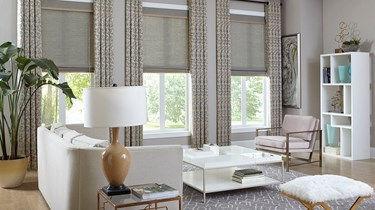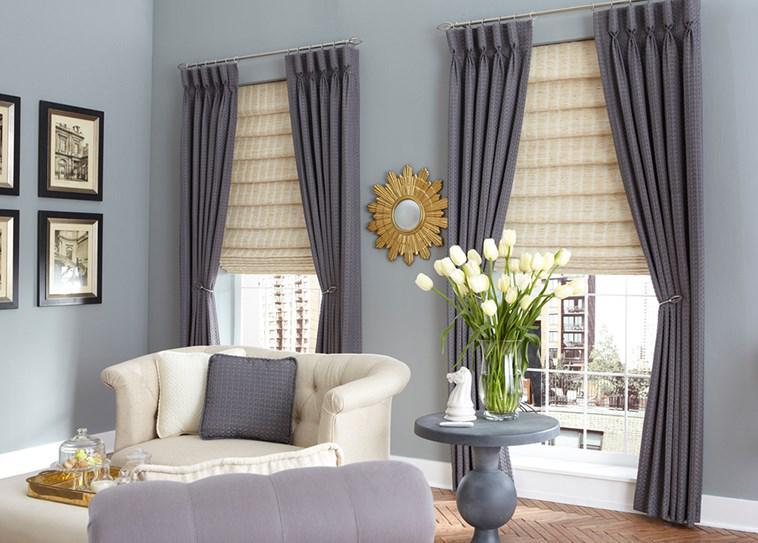The first image is the image on the left, the second image is the image on the right. Evaluate the accuracy of this statement regarding the images: "The right image contains two windows with gray curtains.". Is it true? Answer yes or no. Yes. 